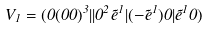<formula> <loc_0><loc_0><loc_500><loc_500>V _ { 1 } = ( 0 ( 0 0 ) ^ { 3 } | | 0 ^ { 2 } { \tilde { e } } ^ { 1 } | ( - { \tilde { e } } ^ { 1 } ) { 0 } | { \tilde { e } } ^ { 1 } { 0 } )</formula> 